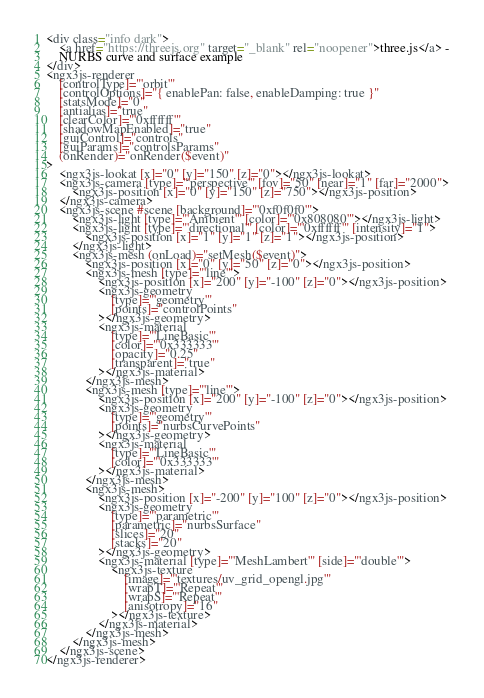<code> <loc_0><loc_0><loc_500><loc_500><_HTML_><div class="info dark">
	<a href="https://threejs.org" target="_blank" rel="noopener">three.js</a> -
	NURBS curve and surface example
</div>
<ngx3js-renderer
	[controlType]="'orbit'"
	[controlOptions]="{ enablePan: false, enableDamping: true }"
	[statsMode]="0"
	[antialias]="true"
	[clearColor]="'0xffffff'"
	[shadowMapEnabled]="true"
	[guiControl]="controls"
	[guiParams]="controlsParams"
	(onRender)="onRender($event)"
>
	<ngx3js-lookat [x]="0" [y]="150" [z]="0"></ngx3js-lookat>
	<ngx3js-camera [type]="'perspective'" [fov]="50" [near]="1" [far]="2000">
		<ngx3js-position [x]="0" [y]="150" [z]="750"></ngx3js-position>
	</ngx3js-camera>
	<ngx3js-scene #scene [background]="'0xf0f0f0'">
		<ngx3js-light [type]="'Ambient'" [color]="'0x808080'"></ngx3js-light>
		<ngx3js-light [type]="'directional'" [color]="'0xffffff'" [intensity]="1">
			<ngx3js-position [x]="1" [y]="1" [z]="1"></ngx3js-position>
		</ngx3js-light>
		<ngx3js-mesh (onLoad)="setMesh($event)">
			<ngx3js-position [x]="0" [y]="50" [z]="0"></ngx3js-position>
			<ngx3js-mesh [type]="'line'">
				<ngx3js-position [x]="200" [y]="-100" [z]="0"></ngx3js-position>
				<ngx3js-geometry
					[type]="'geometry'"
					[points]="controlPoints"
				></ngx3js-geometry>
				<ngx3js-material
					[type]="'LineBasic'"
					[color]="'0x333333'"
					[opacity]="0.25"
					[transparent]="true"
				></ngx3js-material>
			</ngx3js-mesh>
			<ngx3js-mesh [type]="'line'">
				<ngx3js-position [x]="200" [y]="-100" [z]="0"></ngx3js-position>
				<ngx3js-geometry
					[type]="'geometry'"
					[points]="nurbsCurvePoints"
				></ngx3js-geometry>
				<ngx3js-material
					[type]="'LineBasic'"
					[color]="'0x333333'"
				></ngx3js-material>
			</ngx3js-mesh>
			<ngx3js-mesh>
				<ngx3js-position [x]="-200" [y]="100" [z]="0"></ngx3js-position>
				<ngx3js-geometry
					[type]="'parametric'"
					[parametric]="nurbsSurface"
					[slices]="20"
					[stacks]="20"
				></ngx3js-geometry>
				<ngx3js-material [type]="'MeshLambert'" [side]="'double'">
					<ngx3js-texture
						[image]="'textures/uv_grid_opengl.jpg'"
						[wrapT]="'Repeat'"
						[wrapS]="'Repeat'"
						[anisotropy]="16"
					></ngx3js-texture>
				</ngx3js-material>
			</ngx3js-mesh>
		</ngx3js-mesh>
	</ngx3js-scene>
</ngx3js-renderer>
</code> 